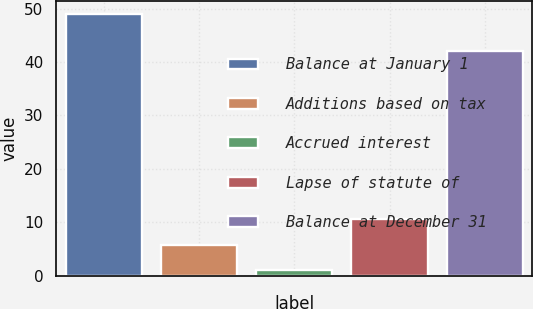<chart> <loc_0><loc_0><loc_500><loc_500><bar_chart><fcel>Balance at January 1<fcel>Additions based on tax<fcel>Accrued interest<fcel>Lapse of statute of<fcel>Balance at December 31<nl><fcel>49<fcel>5.8<fcel>1<fcel>10.6<fcel>42<nl></chart> 